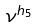<formula> <loc_0><loc_0><loc_500><loc_500>\nu ^ { h _ { 5 } }</formula> 